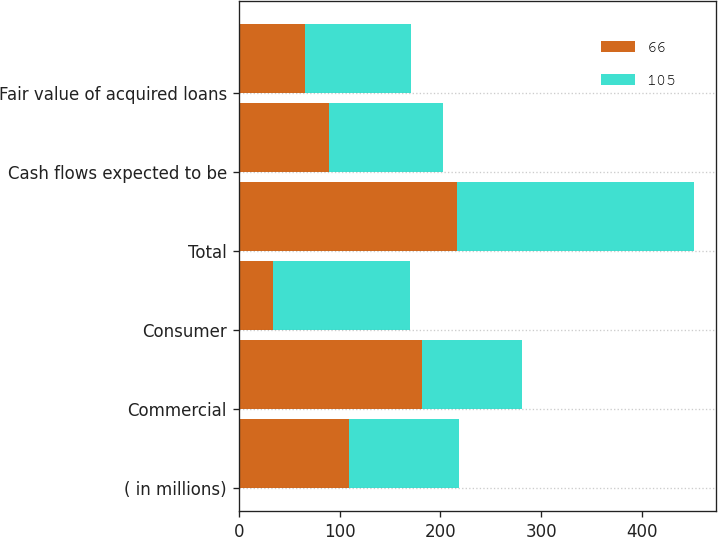Convert chart. <chart><loc_0><loc_0><loc_500><loc_500><stacked_bar_chart><ecel><fcel>( in millions)<fcel>Commercial<fcel>Consumer<fcel>Total<fcel>Cash flows expected to be<fcel>Fair value of acquired loans<nl><fcel>66<fcel>109<fcel>182<fcel>34<fcel>216<fcel>90<fcel>66<nl><fcel>105<fcel>109<fcel>99<fcel>136<fcel>235<fcel>113<fcel>105<nl></chart> 